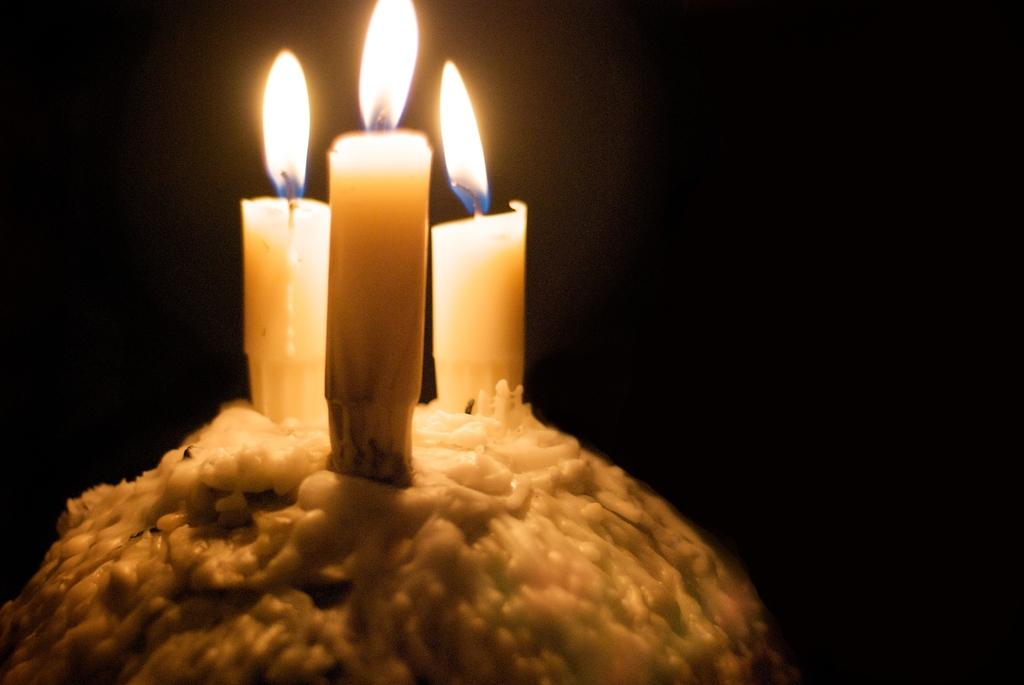How many candles are present in the image? There are three candles in the image. What is the state of the candles in the image? The candles are lit in the image. What is a result of the candles being lit? Melted wax is visible in the image as a result of the candles being lit. What can be inferred about the lighting conditions in the image? The background of the image is dark, which suggests that the candles may be the primary source of light. What type of whistle can be heard in the image? There is no whistle present in the image, and therefore no sound can be heard. 